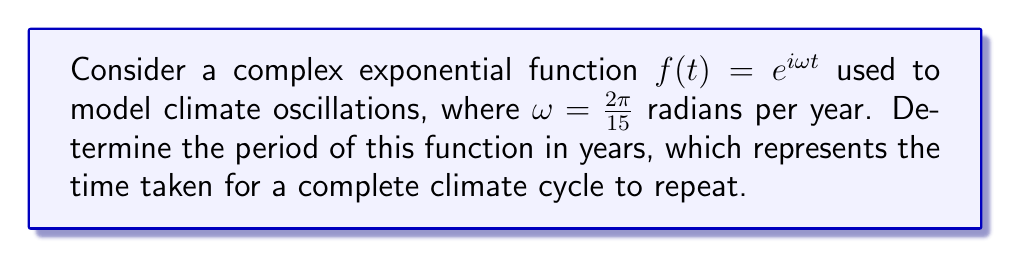What is the answer to this math problem? Let's approach this step-by-step:

1) The general form of a complex exponential function is $f(t) = e^{i\omega t}$, where $\omega$ is the angular frequency.

2) We're given that $\omega = \frac{2\pi}{15}$ radians per year.

3) The period of a complex exponential function is given by the formula:

   $T = \frac{2\pi}{\omega}$

4) Substituting our value of $\omega$:

   $T = \frac{2\pi}{\frac{2\pi}{15}}$

5) Simplify:
   
   $T = 15 \cdot \frac{2\pi}{2\pi} = 15$

6) Therefore, the period of the function is 15 years.

This result suggests that the climate oscillation modeled by this function repeats every 15 years, which aligns with some observed natural climate cycles. However, it's important to note that real climate systems are far more complex and involve multiple interacting cycles of various periods.
Answer: 15 years 